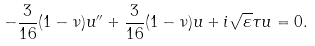Convert formula to latex. <formula><loc_0><loc_0><loc_500><loc_500>- \frac { 3 } { 1 6 } ( 1 - \nu ) u ^ { \prime \prime } + \frac { 3 } { 1 6 } ( 1 - \nu ) u + i \sqrt { \varepsilon } \tau u = 0 .</formula> 